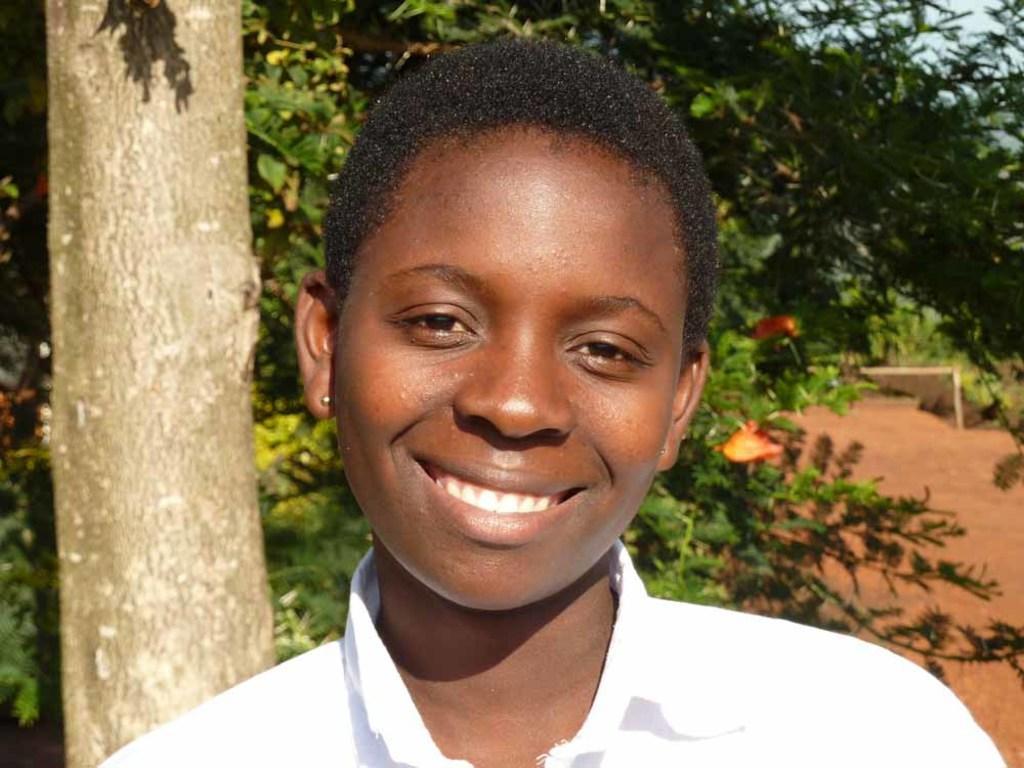Could you give a brief overview of what you see in this image? In this image we can see a person's face who is wearing white color shirt standing at the foreground of the image and at the background of the image there are some trees. 